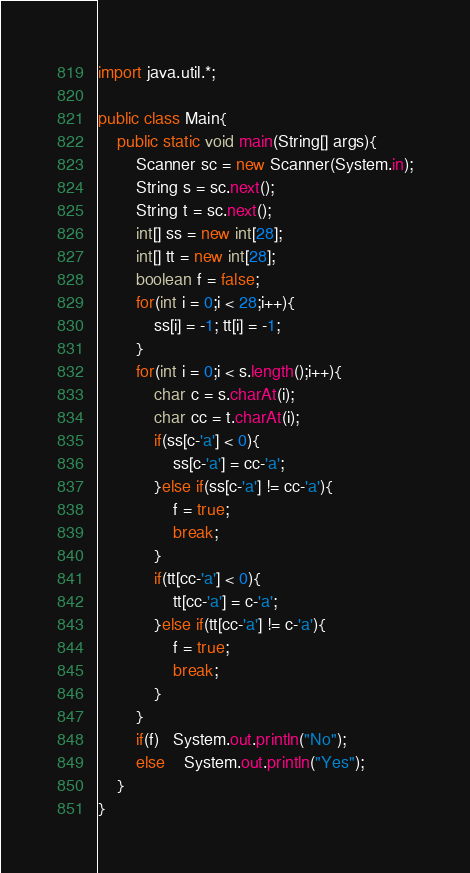Convert code to text. <code><loc_0><loc_0><loc_500><loc_500><_Java_>import java.util.*;

public class Main{
    public static void main(String[] args){
        Scanner sc = new Scanner(System.in);
        String s = sc.next();
        String t = sc.next();
        int[] ss = new int[28];
        int[] tt = new int[28];
        boolean f = false;
        for(int i = 0;i < 28;i++){
            ss[i] = -1; tt[i] = -1;
        }
        for(int i = 0;i < s.length();i++){
            char c = s.charAt(i);
            char cc = t.charAt(i);
            if(ss[c-'a'] < 0){
                ss[c-'a'] = cc-'a';
            }else if(ss[c-'a'] != cc-'a'){
                f = true;
                break;
            }
            if(tt[cc-'a'] < 0){
                tt[cc-'a'] = c-'a';
            }else if(tt[cc-'a'] != c-'a'){
                f = true;
                break;
            }
        }
        if(f)   System.out.println("No");
        else    System.out.println("Yes");
    }
}</code> 